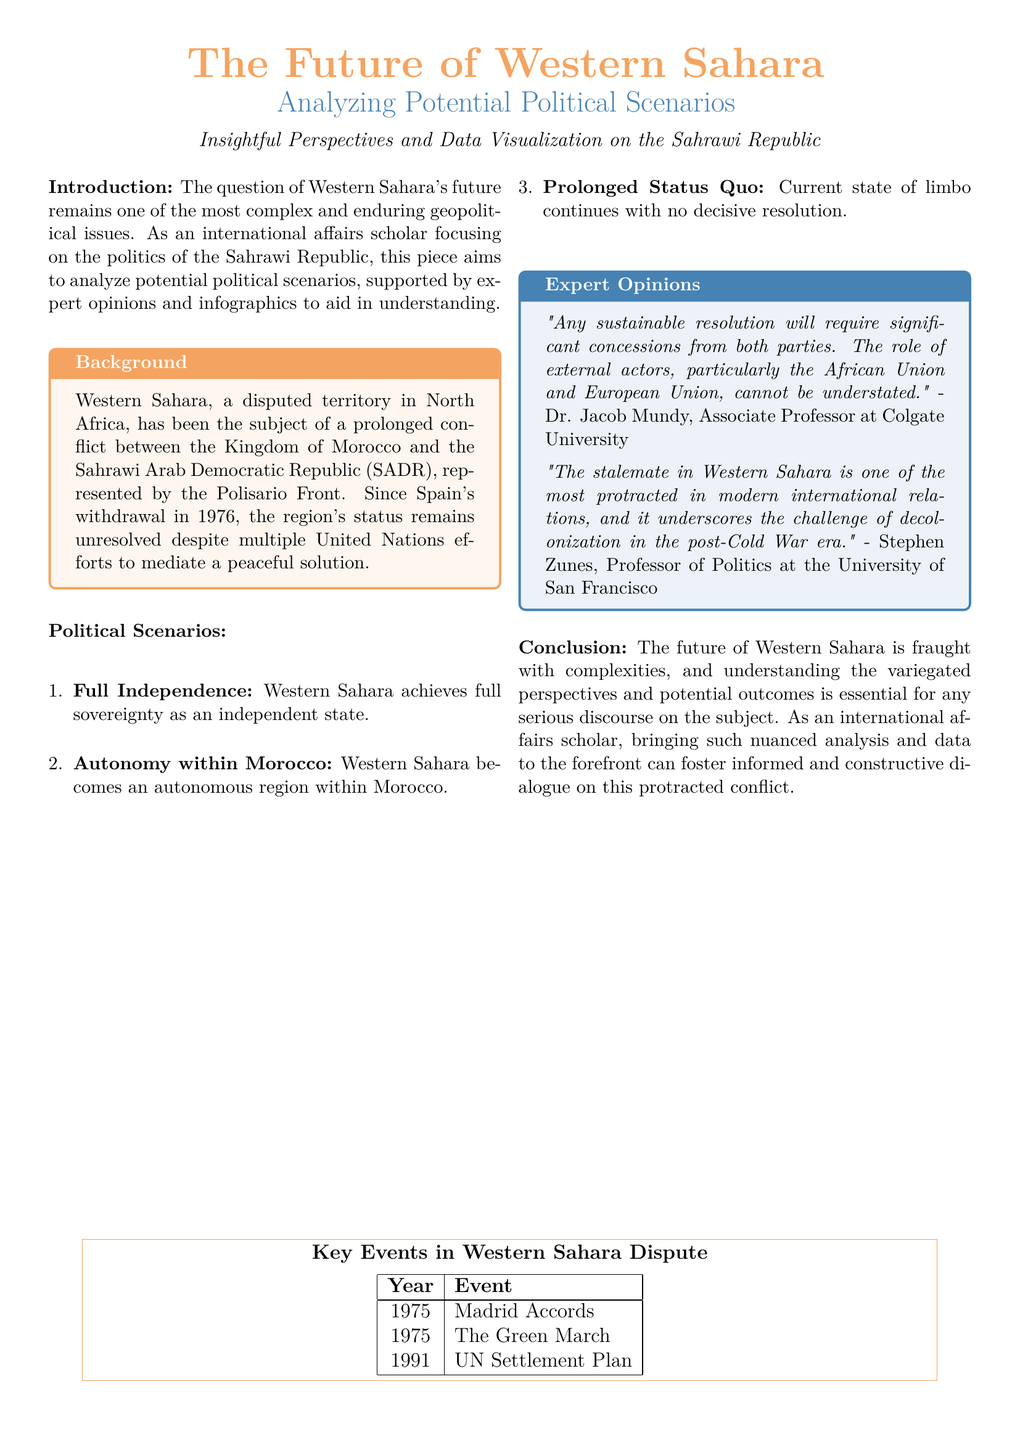What year did Spain withdraw from Western Sahara? The document states that Spain's withdrawal occurred in 1976.
Answer: 1976 Who represents the Sahrawi Arab Democratic Republic? The document mentions that the Polisario Front represents the SADR.
Answer: Polisario Front What is one potential political scenario for Western Sahara? The document lists three potential scenarios, one being "Full Independence."
Answer: Full Independence Who provided an expert opinion stating that sustainable resolution requires concessions? The document cites Dr. Jacob Mundy as the expert who made this statement.
Answer: Dr. Jacob Mundy What significant event occurred in 1991 related to the Western Sahara conflict? The document includes "UN Settlement Plan" as the event that took place in 1991.
Answer: UN Settlement Plan What color is used for the title "Analyzing Potential Political Scenarios"? The title is highlighted in desert blue color.
Answer: desert blue How many potential political scenarios are discussed in the document? The document outlines three potential political scenarios.
Answer: Three What major event is listed in 1975? The document lists "The Green March" as a significant event in this year.
Answer: The Green March Which professor stated that the stalemate underscores the challenge of decolonization? The document attributes this statement to Stephen Zunes.
Answer: Stephen Zunes 